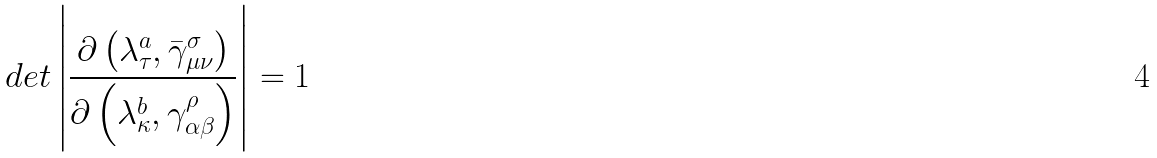<formula> <loc_0><loc_0><loc_500><loc_500>d e t \left | \frac { \partial \left ( \lambda _ { \tau } ^ { a } , \bar { \gamma } _ { \mu \nu } ^ { \sigma } \right ) } { \partial \left ( \lambda _ { \kappa } ^ { b } , \gamma _ { \alpha \beta } ^ { \rho } \right ) } \right | = 1</formula> 